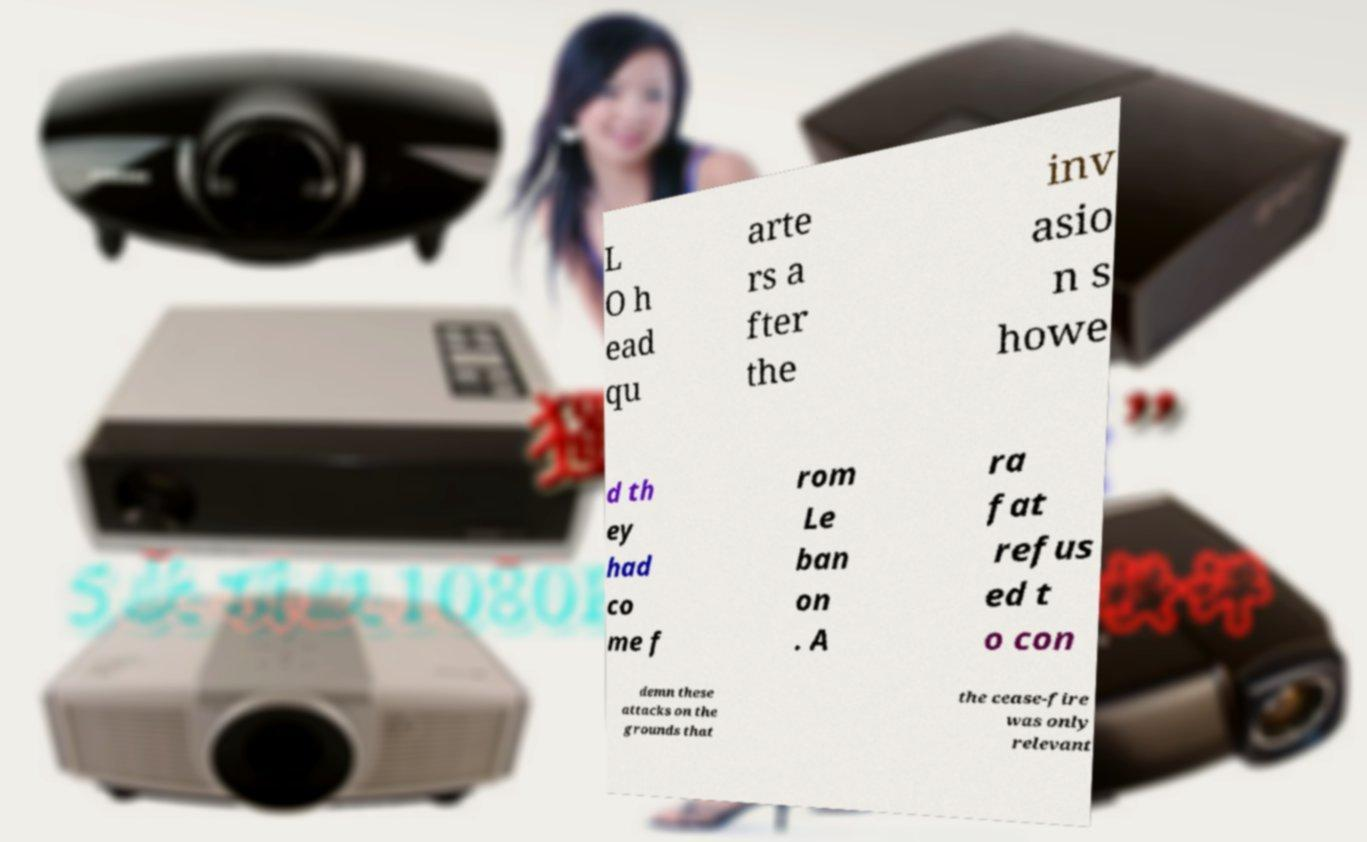Could you assist in decoding the text presented in this image and type it out clearly? L O h ead qu arte rs a fter the inv asio n s howe d th ey had co me f rom Le ban on . A ra fat refus ed t o con demn these attacks on the grounds that the cease-fire was only relevant 